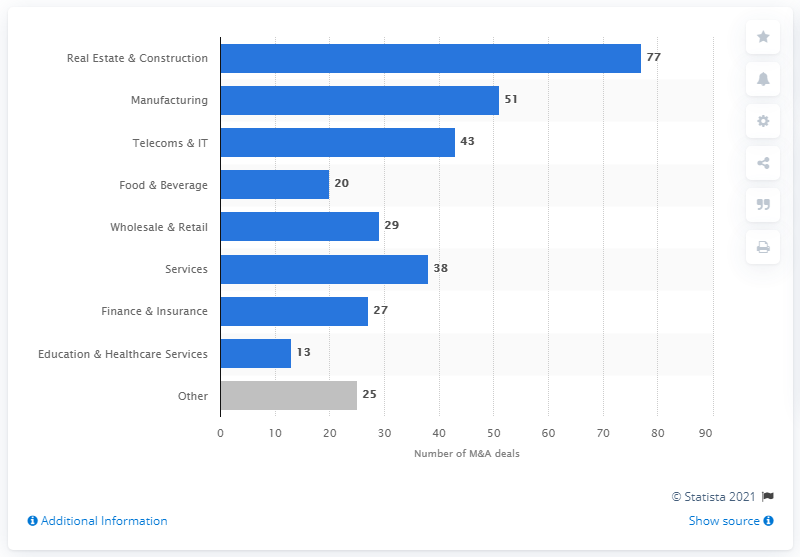Which sector had the second-highest number of transactions in Poland in 2018? In 2018, the Manufacturing sector had the second-highest number of transactions in Poland, with a total of 51 deals as illustrated by the bar chart. 